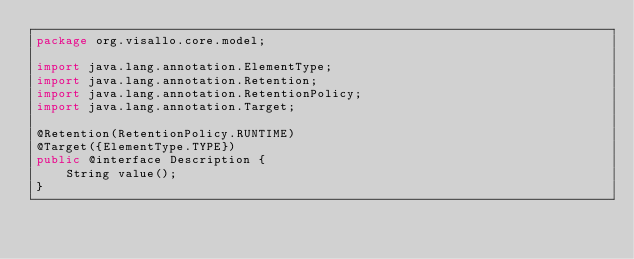Convert code to text. <code><loc_0><loc_0><loc_500><loc_500><_Java_>package org.visallo.core.model;

import java.lang.annotation.ElementType;
import java.lang.annotation.Retention;
import java.lang.annotation.RetentionPolicy;
import java.lang.annotation.Target;

@Retention(RetentionPolicy.RUNTIME)
@Target({ElementType.TYPE})
public @interface Description {
    String value();
}
</code> 